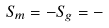<formula> <loc_0><loc_0><loc_500><loc_500>S _ { m } = - S _ { g } = -</formula> 